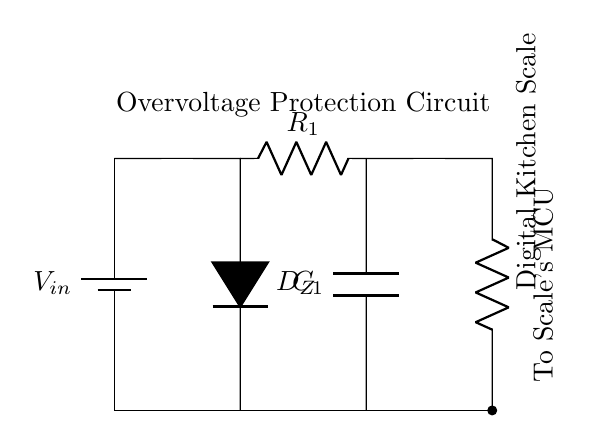What is the type of diode used in the circuit? The circuit includes a Zener diode, denoted as D_Z. This is specifically designed for voltage regulation and allows current to flow in the reverse direction when a specific threshold is reached.
Answer: Zener diode What does the resistor R1 help to do in this circuit? The resistor R1 is used to limit the current flowing through the Zener diode, which helps protect the other components from overcurrent. It ensures proper operation of the Zener diode by preventing excessive current that could lead to failure.
Answer: Limit current What is the purpose of capacitor C1? The capacitor C1 functions as a smoothing element, aiding in the stabilization of the voltage output and filtering out noise in the circuit, which is crucial for the accurate operation of the digital kitchen scale.
Answer: Smoothing How does the Zener diode protect the digital kitchen scale? The Zener diode protects the scale by clamping the voltage to a safe level. If input voltage exceeds its breakdown voltage, it allows excess voltage to be diverted away from the scale, preventing damage.
Answer: Clamp voltage What is the main function of this circuit? The primary function of the circuit is to provide overvoltage protection for the digital kitchen scale by regulating input voltage and ensuring the scale operates safely within its specified limits.
Answer: Overvoltage protection 